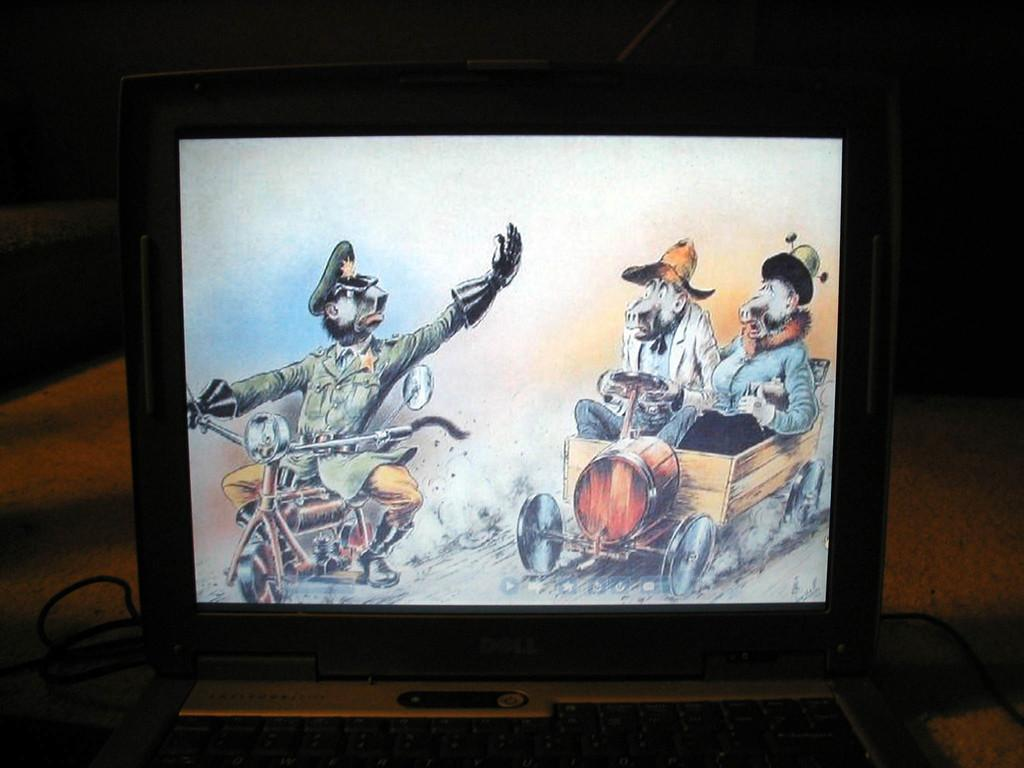<image>
Share a concise interpretation of the image provided. A cartoon illustration featuring a police office is shown on a Dell laptop. 